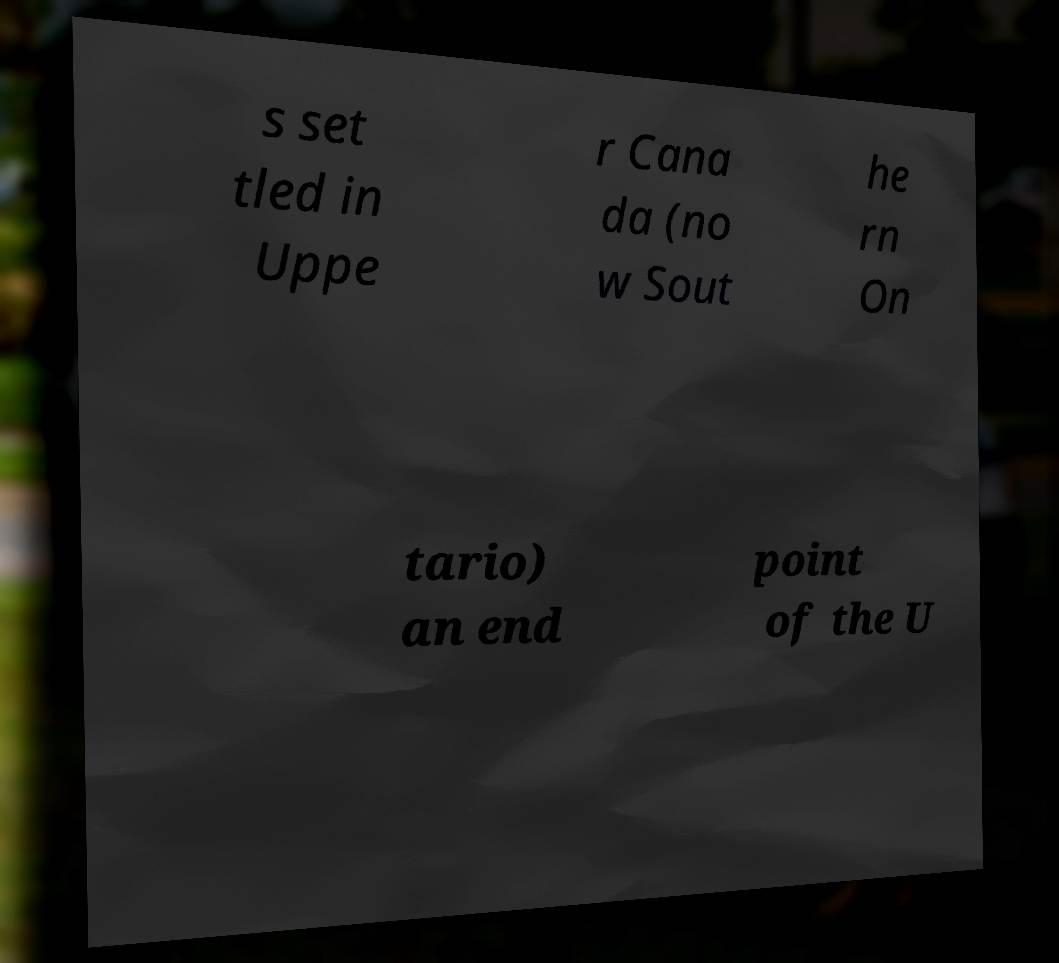Could you extract and type out the text from this image? s set tled in Uppe r Cana da (no w Sout he rn On tario) an end point of the U 